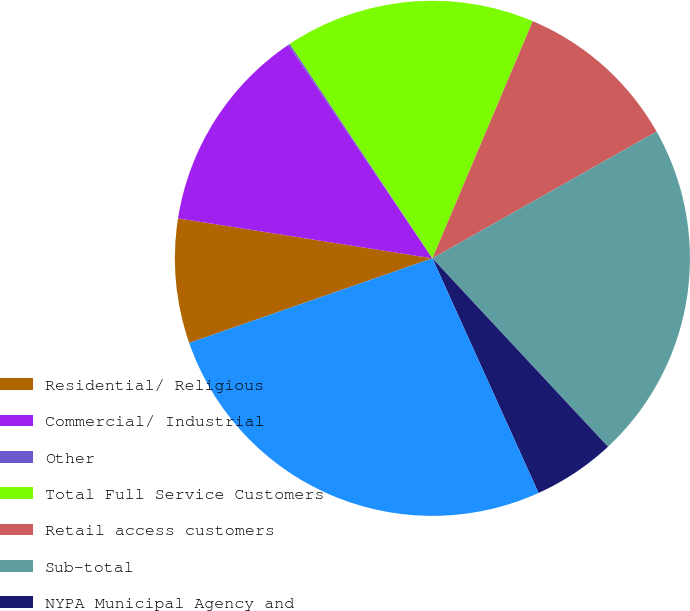Convert chart. <chart><loc_0><loc_0><loc_500><loc_500><pie_chart><fcel>Residential/ Religious<fcel>Commercial/ Industrial<fcel>Other<fcel>Total Full Service Customers<fcel>Retail access customers<fcel>Sub-total<fcel>NYPA Municipal Agency and<fcel>Total Service Area<nl><fcel>7.81%<fcel>13.07%<fcel>0.11%<fcel>15.71%<fcel>10.44%<fcel>21.25%<fcel>5.18%<fcel>26.43%<nl></chart> 